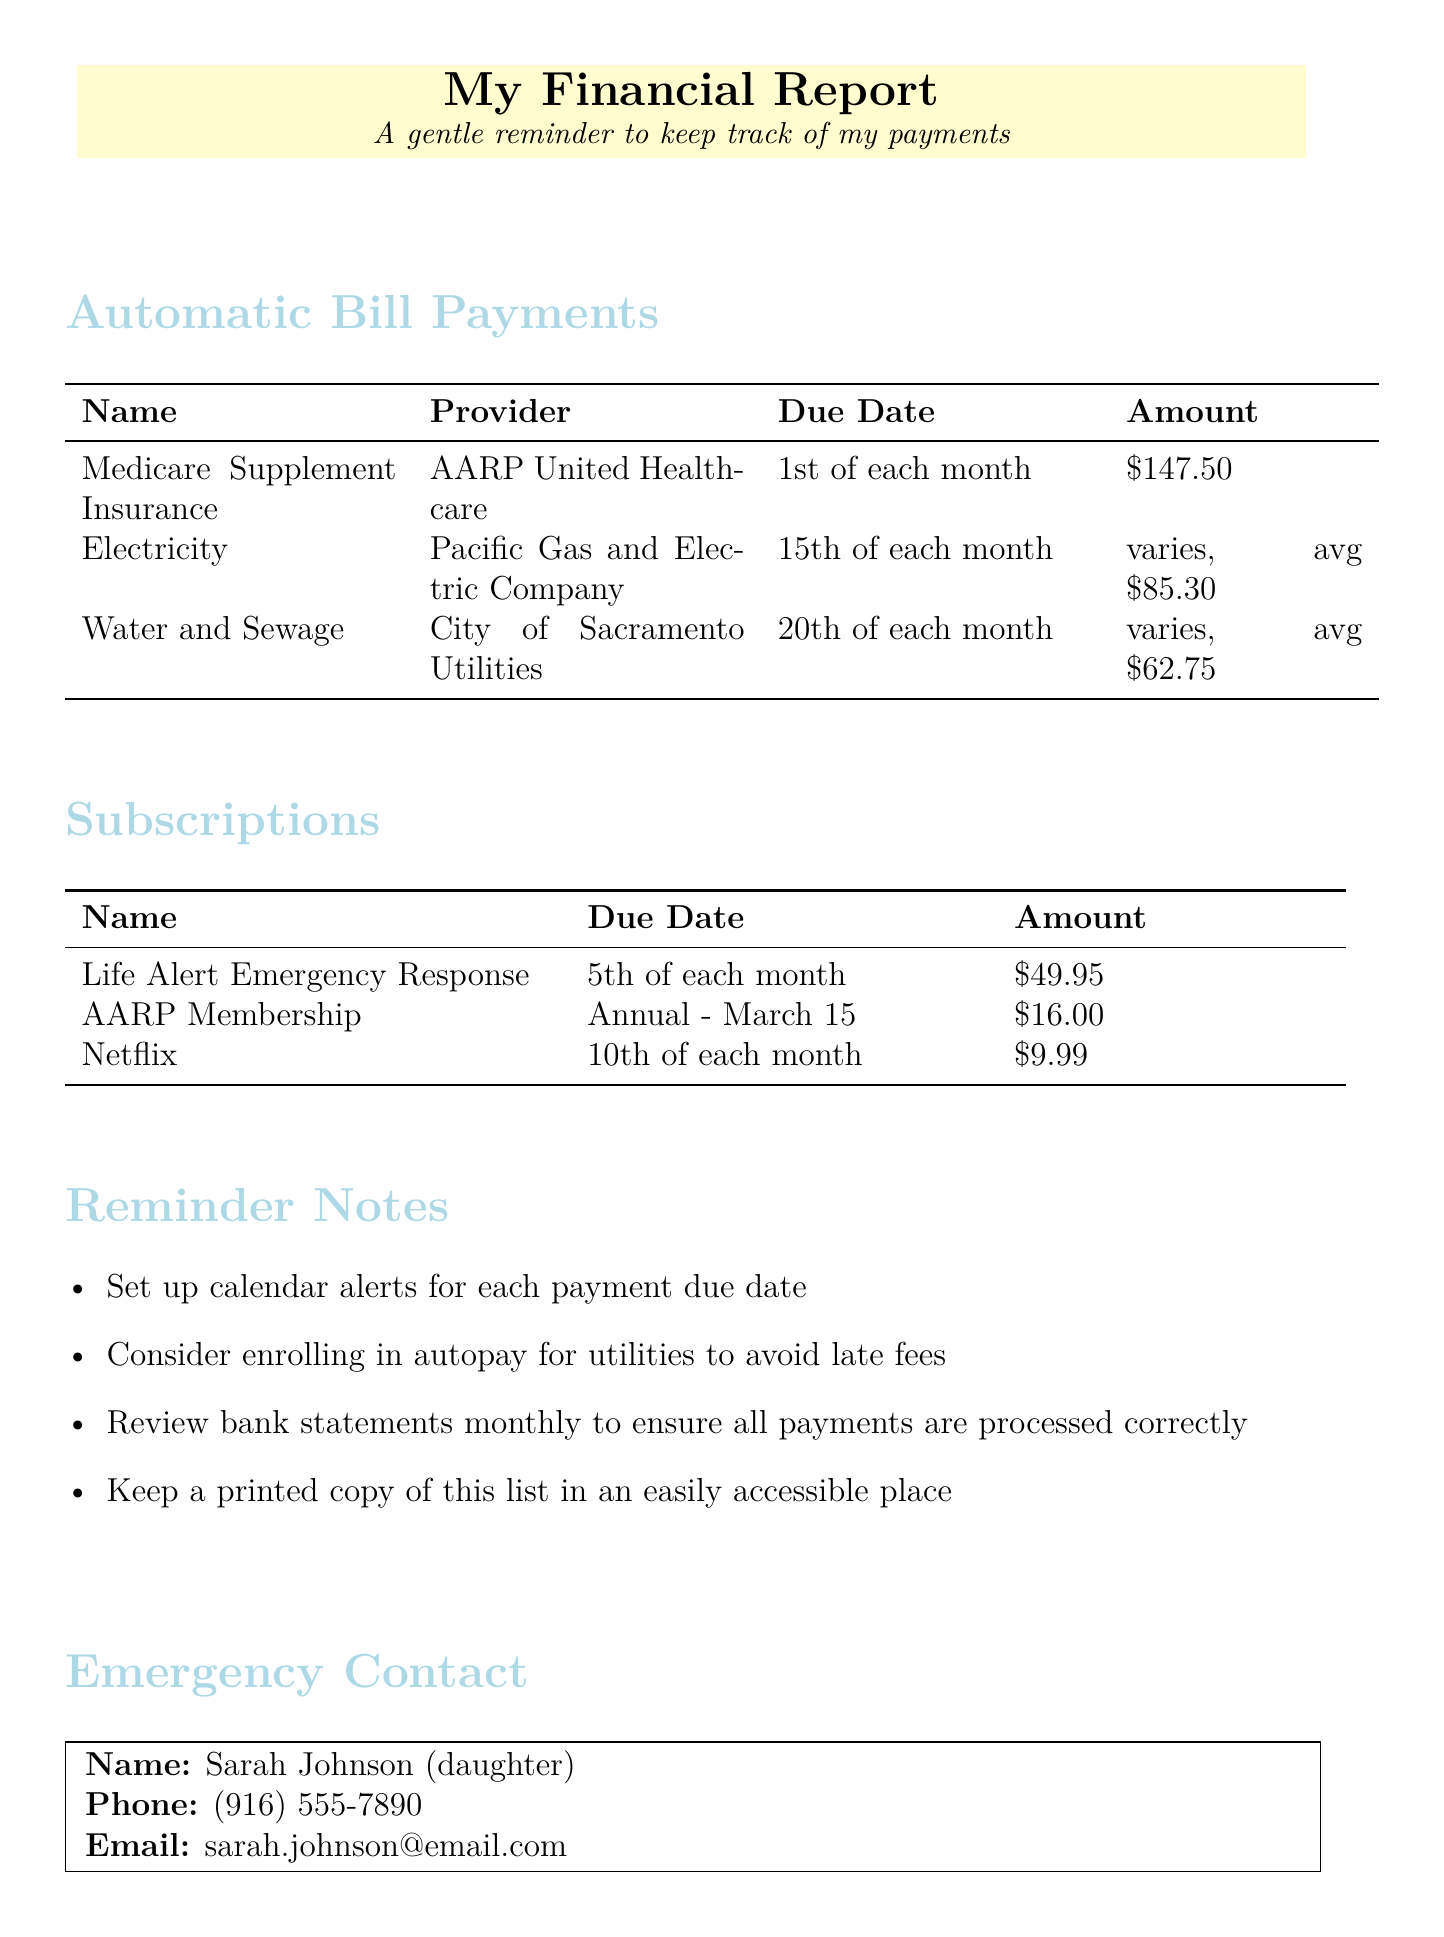What is the due date for Medicare Supplement Insurance? The due date for Medicare Supplement Insurance is the 1st of each month.
Answer: 1st of each month How much is the monthly payment for Netflix? The document states that the amount for Netflix is $9.99.
Answer: $9.99 Who provides the Water and Sewage service? The provider for Water and Sewage is City of Sacramento Utilities.
Answer: City of Sacramento Utilities When is the annual payment for AARP Membership due? The due date for the AARP Membership is March 15 each year.
Answer: March 15 What payment method is suggested to avoid late fees on utilities? The document suggests considering enrollment in autopay for utilities.
Answer: Autopay How much is the average amount for electricity payments? The average amount mentioned for electricity is $85.30.
Answer: $85.30 What should be kept in an easily accessible place? The reminder notes suggest keeping a printed copy of this list in an easily accessible place.
Answer: Printed copy of this list Who is the emergency contact? The emergency contact listed is Sarah Johnson.
Answer: Sarah Johnson What type of report is this document? This document is a financial report.
Answer: Financial report 